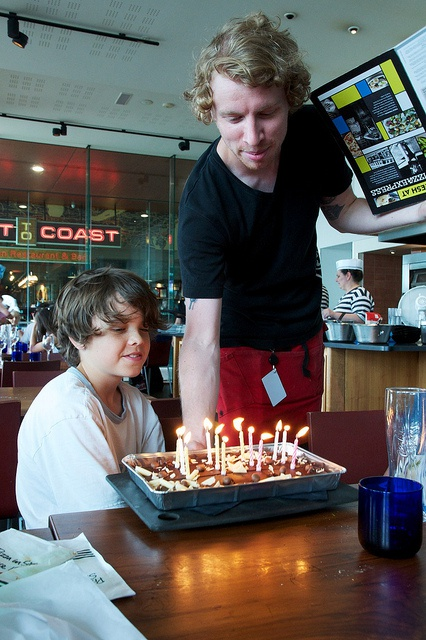Describe the objects in this image and their specific colors. I can see people in gray, black, maroon, and darkgray tones, dining table in gray, maroon, black, brown, and lightblue tones, people in gray, lightblue, black, and darkgray tones, cake in gray, ivory, maroon, and brown tones, and cup in gray, black, navy, darkblue, and blue tones in this image. 